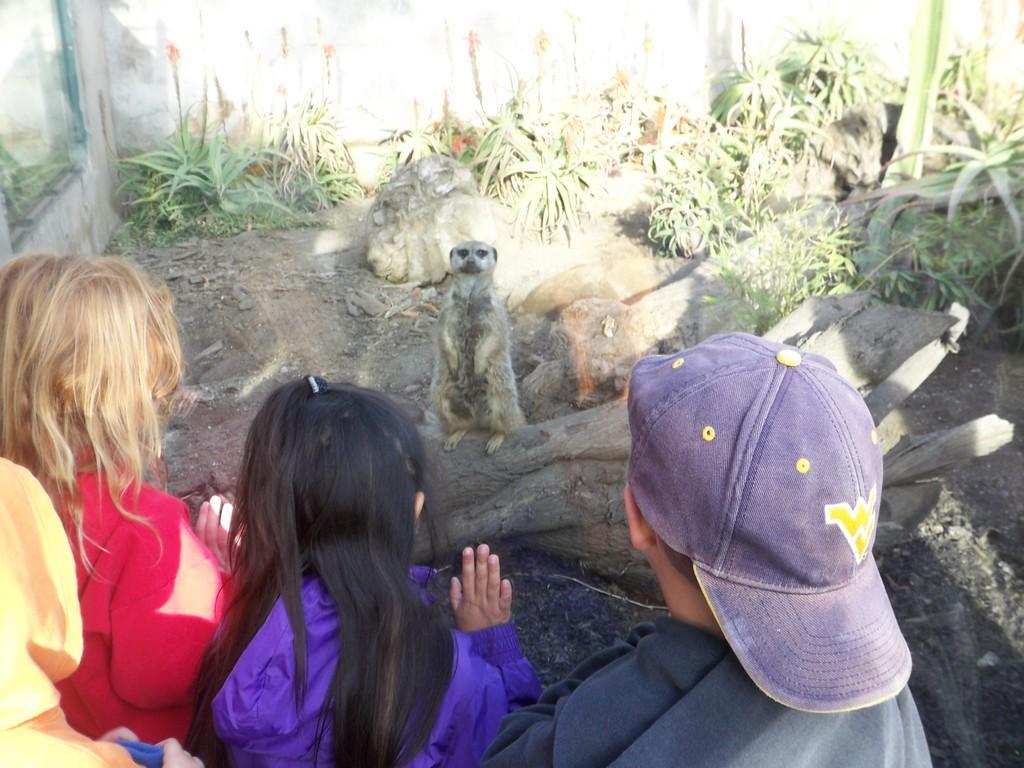In one or two sentences, can you explain what this image depicts? In the middle a Meerkat is standing on a bark of a tree, here few people are looking at this animal. In the right side there are plants. 